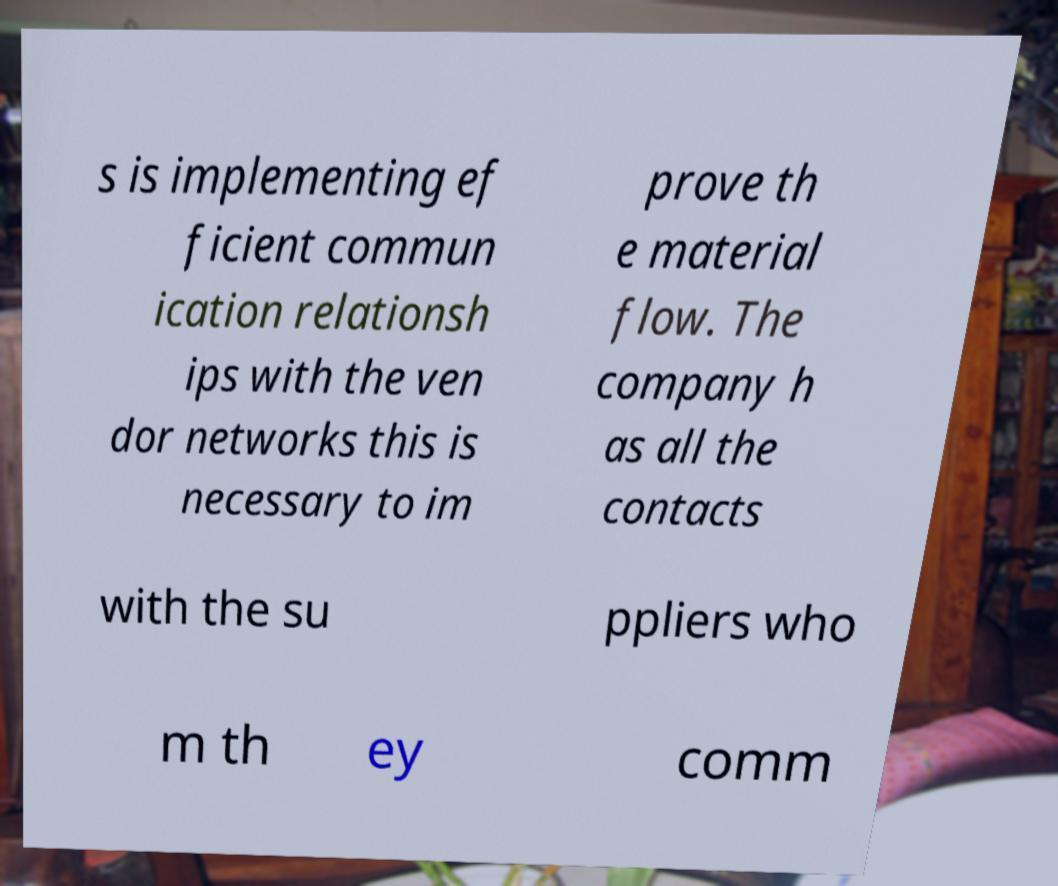Please read and relay the text visible in this image. What does it say? s is implementing ef ficient commun ication relationsh ips with the ven dor networks this is necessary to im prove th e material flow. The company h as all the contacts with the su ppliers who m th ey comm 